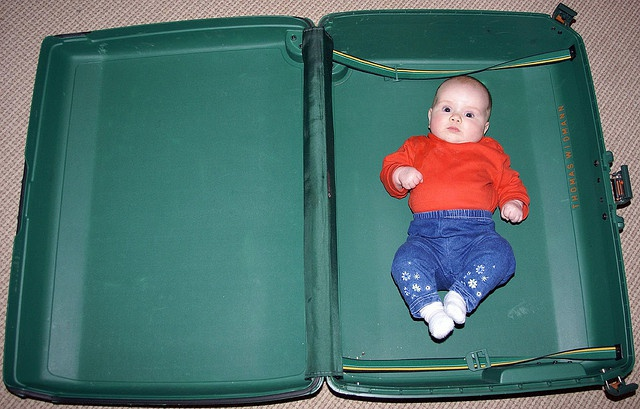Describe the objects in this image and their specific colors. I can see suitcase in teal, gray, and black tones and people in gray, blue, red, and lightgray tones in this image. 